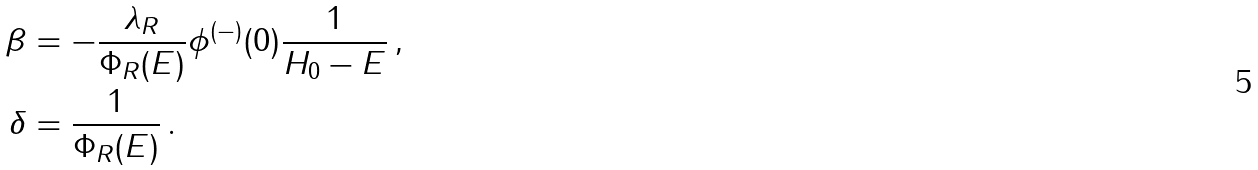<formula> <loc_0><loc_0><loc_500><loc_500>\beta & = - \frac { \lambda _ { R } } { \Phi _ { R } ( E ) } \phi ^ { ( - ) } ( 0 ) \frac { 1 } { H _ { 0 } - E } \, , \\ \delta & = \frac { 1 } { \Phi _ { R } ( E ) } \, .</formula> 